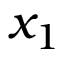Convert formula to latex. <formula><loc_0><loc_0><loc_500><loc_500>x _ { 1 }</formula> 